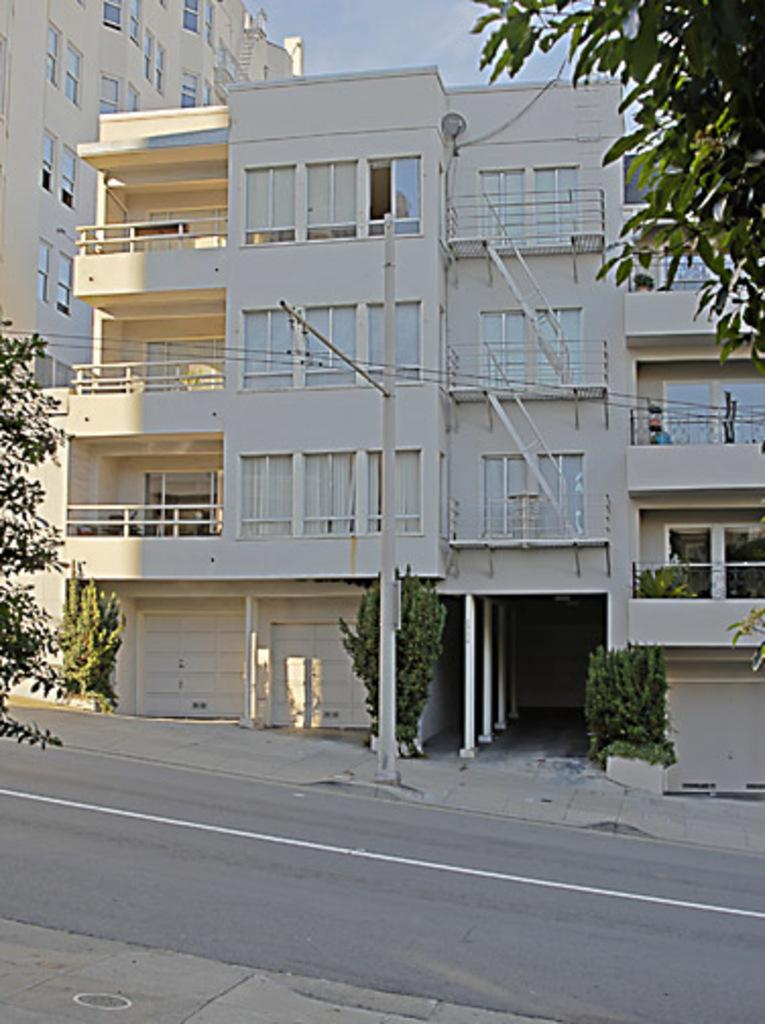What type of structures can be seen in the image? There are buildings in the image. What other natural elements are present in the image? There are trees in the image. What is attached to the pole in the image? There are wires attached to the pole in the image. What is visible in the background of the image? The sky is visible in the image. What can be found at the bottom of the image? There is a road and a path at the bottom of the image. What time of day is it in the image, and how does it affect the need for a step? The time of day is not mentioned in the image, and there is no indication of a need for a step. 